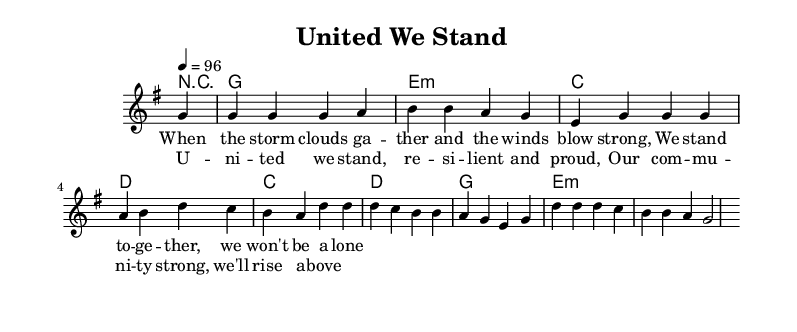What is the key signature of this music? The key signature is G major, which has one sharp (F#). This can be identified by looking at the key signature indicated at the beginning of the staff.
Answer: G major What is the time signature of this music? The time signature is 4/4, which is evident from the notation shown at the beginning of the score. This means there are four beats in each measure, and a quarter note receives one beat.
Answer: 4/4 What is the tempo of this music? The tempo marking indicates a speed of 96 beats per minute. This is stated explicitly at the beginning of the score under the tempo indication.
Answer: 96 How many measures are in the melody section? The melody section contains eight measures. Counting the vertical lines in the score where the measures are separated confirms this.
Answer: 8 What is the primary theme conveyed in the lyrics? The lyrics focus on unity and resilience during challenging times, emphasizing community strength. Analyzing the text provided shows that it addresses people coming together in adversity.
Answer: Unity What chords are used in the first measure? The chord used in the first measure is G major, as indicated in the chord symbols above the melody. This is the first chord listed in the chord progression.
Answer: G What musical genre does this piece represent? This piece represents the Rhythm and Blues genre, which is characterized by its emphasis on community themes, emotional expression, and a soulful style evident in both the melody and lyrics.
Answer: Rhythm and Blues 